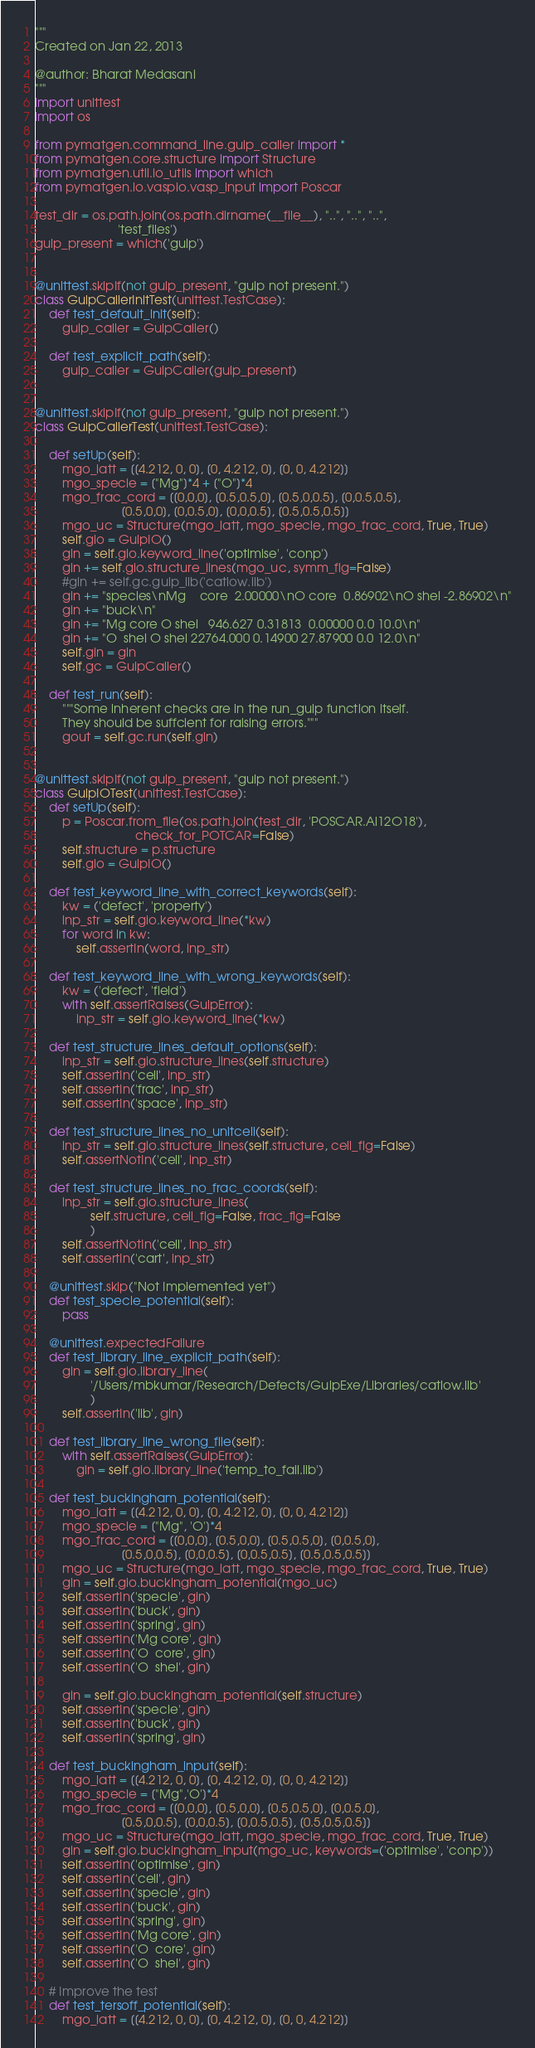Convert code to text. <code><loc_0><loc_0><loc_500><loc_500><_Python_>"""
Created on Jan 22, 2013

@author: Bharat Medasani
"""
import unittest
import os

from pymatgen.command_line.gulp_caller import *
from pymatgen.core.structure import Structure
from pymatgen.util.io_utils import which
from pymatgen.io.vaspio.vasp_input import Poscar

test_dir = os.path.join(os.path.dirname(__file__), "..", "..", "..",
                        'test_files')
gulp_present = which('gulp')


@unittest.skipIf(not gulp_present, "gulp not present.")
class GulpCallerInitTest(unittest.TestCase):
    def test_default_init(self):
        gulp_caller = GulpCaller()

    def test_explicit_path(self):
        gulp_caller = GulpCaller(gulp_present)


@unittest.skipIf(not gulp_present, "gulp not present.")
class GulpCallerTest(unittest.TestCase):

    def setUp(self):
        mgo_latt = [[4.212, 0, 0], [0, 4.212, 0], [0, 0, 4.212]]
        mgo_specie = ["Mg"]*4 + ["O"]*4
        mgo_frac_cord = [[0,0,0], [0.5,0.5,0], [0.5,0,0.5], [0,0.5,0.5],
                         [0.5,0,0], [0,0.5,0], [0,0,0.5], [0.5,0.5,0.5]]
        mgo_uc = Structure(mgo_latt, mgo_specie, mgo_frac_cord, True, True)
        self.gio = GulpIO()
        gin = self.gio.keyword_line('optimise', 'conp')
        gin += self.gio.structure_lines(mgo_uc, symm_flg=False)
        #gin += self.gc.gulp_lib('catlow.lib')
        gin += "species\nMg    core  2.00000\nO core  0.86902\nO shel -2.86902\n"
        gin += "buck\n"
        gin += "Mg core O shel   946.627 0.31813  0.00000 0.0 10.0\n"
        gin += "O  shel O shel 22764.000 0.14900 27.87900 0.0 12.0\n"
        self.gin = gin
        self.gc = GulpCaller()

    def test_run(self):
        """Some inherent checks are in the run_gulp function itself.
        They should be suffcient for raising errors."""
        gout = self.gc.run(self.gin)


@unittest.skipIf(not gulp_present, "gulp not present.")
class GulpIOTest(unittest.TestCase):
    def setUp(self):
        p = Poscar.from_file(os.path.join(test_dir, 'POSCAR.Al12O18'),
                             check_for_POTCAR=False)
        self.structure = p.structure
        self.gio = GulpIO()

    def test_keyword_line_with_correct_keywords(self):
        kw = ('defect', 'property')
        inp_str = self.gio.keyword_line(*kw)
        for word in kw:
            self.assertIn(word, inp_str)

    def test_keyword_line_with_wrong_keywords(self):
        kw = ('defect', 'field')
        with self.assertRaises(GulpError):
            inp_str = self.gio.keyword_line(*kw)

    def test_structure_lines_default_options(self):
        inp_str = self.gio.structure_lines(self.structure)
        self.assertIn('cell', inp_str)
        self.assertIn('frac', inp_str)
        self.assertIn('space', inp_str)

    def test_structure_lines_no_unitcell(self):
        inp_str = self.gio.structure_lines(self.structure, cell_flg=False)
        self.assertNotIn('cell', inp_str)

    def test_structure_lines_no_frac_coords(self):
        inp_str = self.gio.structure_lines(
                self.structure, cell_flg=False, frac_flg=False
                )
        self.assertNotIn('cell', inp_str)
        self.assertIn('cart', inp_str)

    @unittest.skip("Not Implemented yet")
    def test_specie_potential(self):
        pass

    @unittest.expectedFailure
    def test_library_line_explicit_path(self):
        gin = self.gio.library_line(
                '/Users/mbkumar/Research/Defects/GulpExe/Libraries/catlow.lib'
                )
        self.assertIn('lib', gin)

    def test_library_line_wrong_file(self):
        with self.assertRaises(GulpError):
            gin = self.gio.library_line('temp_to_fail.lib')

    def test_buckingham_potential(self):
        mgo_latt = [[4.212, 0, 0], [0, 4.212, 0], [0, 0, 4.212]]
        mgo_specie = ["Mg", 'O']*4
        mgo_frac_cord = [[0,0,0], [0.5,0,0], [0.5,0.5,0], [0,0.5,0],
                         [0.5,0,0.5], [0,0,0.5], [0,0.5,0.5], [0.5,0.5,0.5]]
        mgo_uc = Structure(mgo_latt, mgo_specie, mgo_frac_cord, True, True)
        gin = self.gio.buckingham_potential(mgo_uc)
        self.assertIn('specie', gin)
        self.assertIn('buck', gin)
        self.assertIn('spring', gin)
        self.assertIn('Mg core', gin)
        self.assertIn('O  core', gin)
        self.assertIn('O  shel', gin)

        gin = self.gio.buckingham_potential(self.structure)
        self.assertIn('specie', gin)
        self.assertIn('buck', gin)
        self.assertIn('spring', gin)

    def test_buckingham_input(self):
        mgo_latt = [[4.212, 0, 0], [0, 4.212, 0], [0, 0, 4.212]]
        mgo_specie = ["Mg",'O']*4 
        mgo_frac_cord = [[0,0,0], [0.5,0,0], [0.5,0.5,0], [0,0.5,0],
                         [0.5,0,0.5], [0,0,0.5], [0,0.5,0.5], [0.5,0.5,0.5]]
        mgo_uc = Structure(mgo_latt, mgo_specie, mgo_frac_cord, True, True)
        gin = self.gio.buckingham_input(mgo_uc, keywords=('optimise', 'conp'))
        self.assertIn('optimise', gin)
        self.assertIn('cell', gin)
        self.assertIn('specie', gin)
        self.assertIn('buck', gin)
        self.assertIn('spring', gin)
        self.assertIn('Mg core', gin)
        self.assertIn('O  core', gin)
        self.assertIn('O  shel', gin)

    # Improve the test 
    def test_tersoff_potential(self):
        mgo_latt = [[4.212, 0, 0], [0, 4.212, 0], [0, 0, 4.212]]</code> 